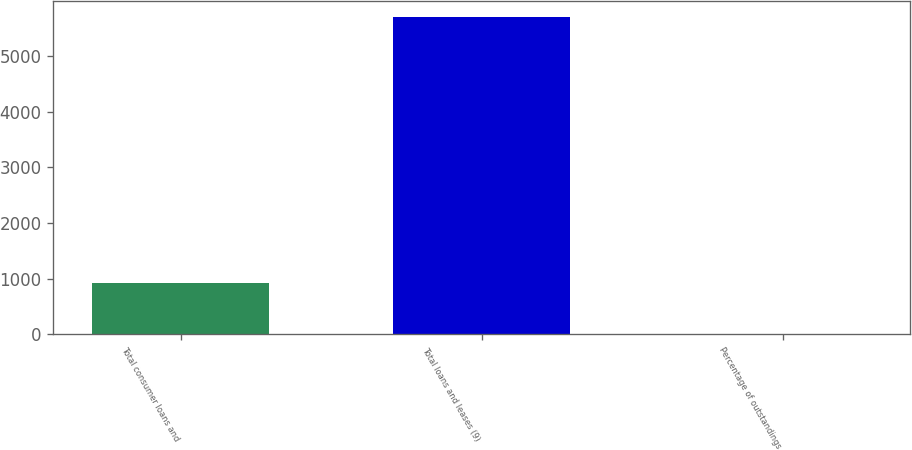Convert chart. <chart><loc_0><loc_0><loc_500><loc_500><bar_chart><fcel>Total consumer loans and<fcel>Total loans and leases (9)<fcel>Percentage of outstandings<nl><fcel>928<fcel>5710<fcel>0.61<nl></chart> 